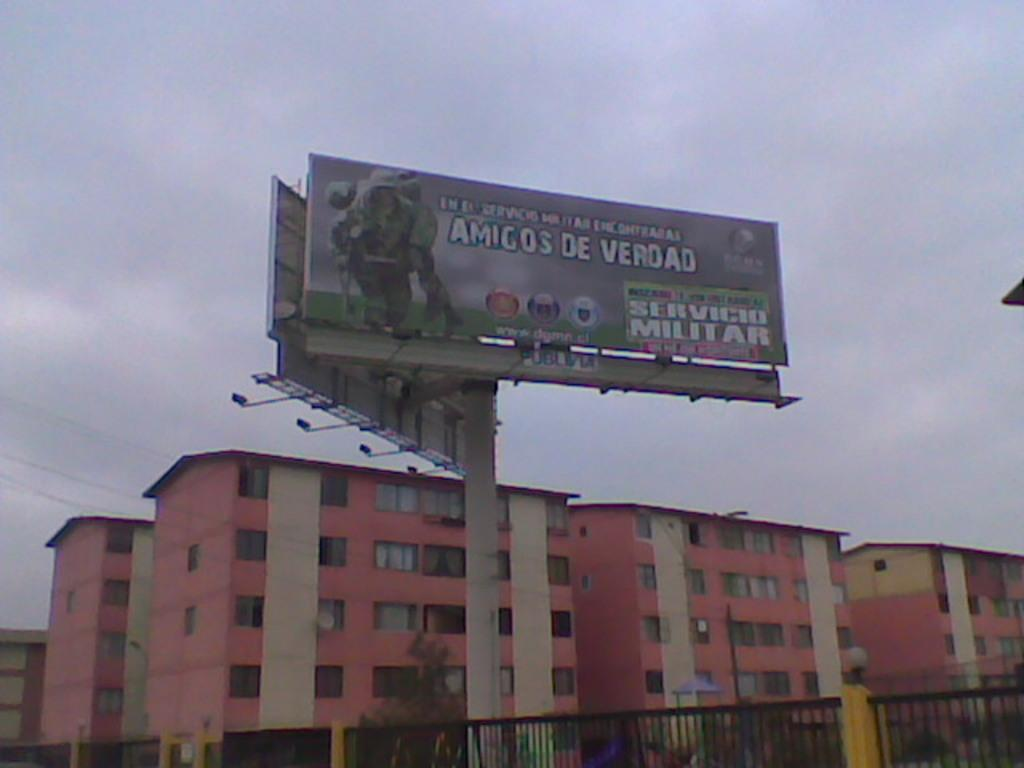<image>
Relay a brief, clear account of the picture shown. Apartment buildings sit beyond a billboard that displays a military ad that is written in Spanish. 